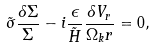<formula> <loc_0><loc_0><loc_500><loc_500>\tilde { \sigma } \frac { \delta \Sigma } { \Sigma } - i \frac { \epsilon } { \tilde { H } } \frac { \delta V _ { r } } { \Omega _ { k } r } = 0 ,</formula> 